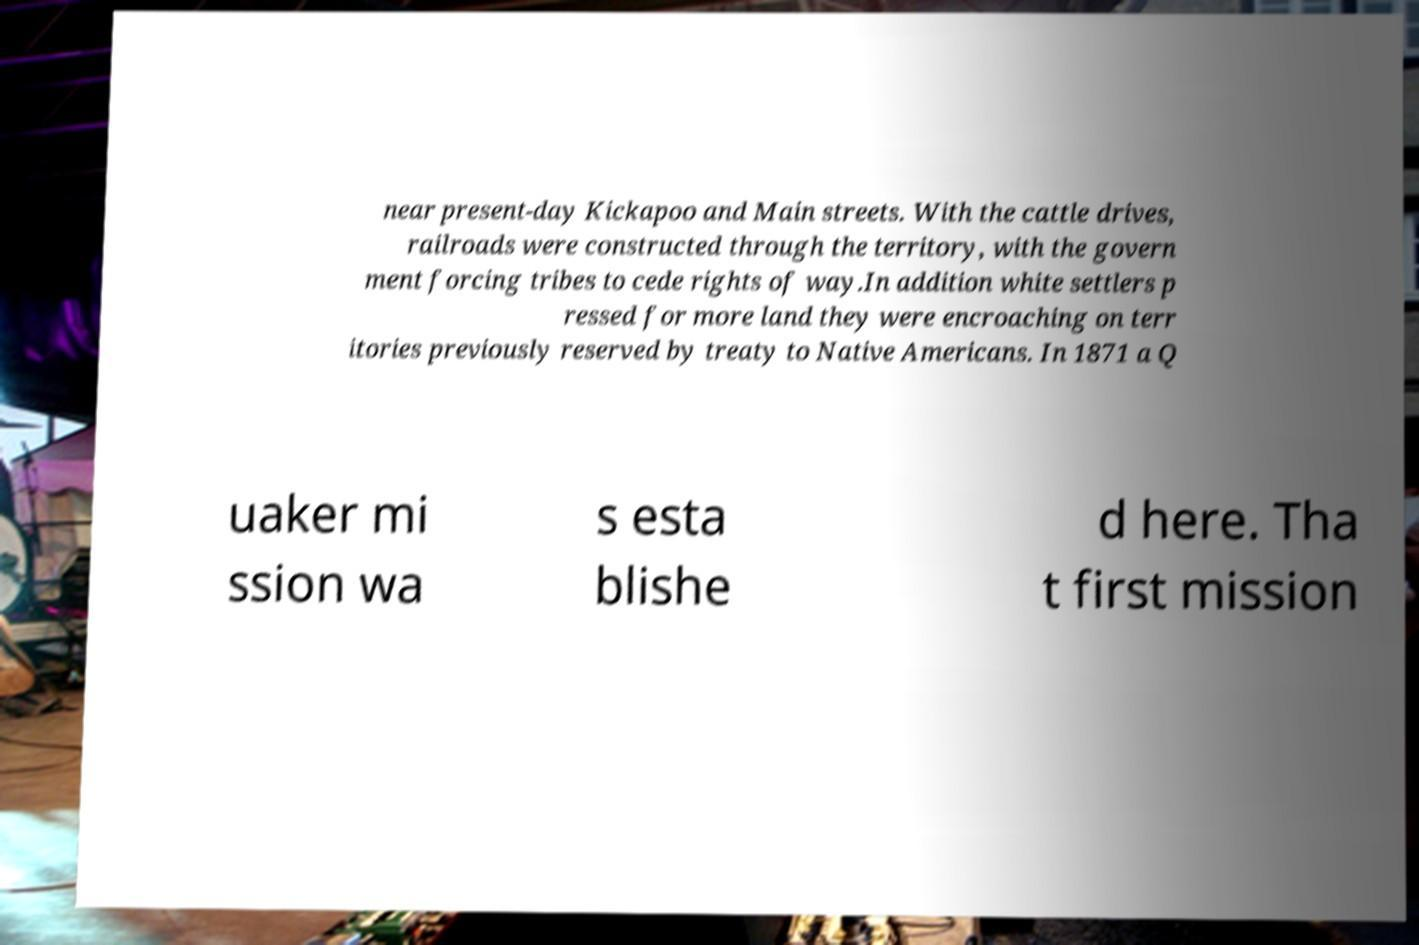I need the written content from this picture converted into text. Can you do that? near present-day Kickapoo and Main streets. With the cattle drives, railroads were constructed through the territory, with the govern ment forcing tribes to cede rights of way.In addition white settlers p ressed for more land they were encroaching on terr itories previously reserved by treaty to Native Americans. In 1871 a Q uaker mi ssion wa s esta blishe d here. Tha t first mission 